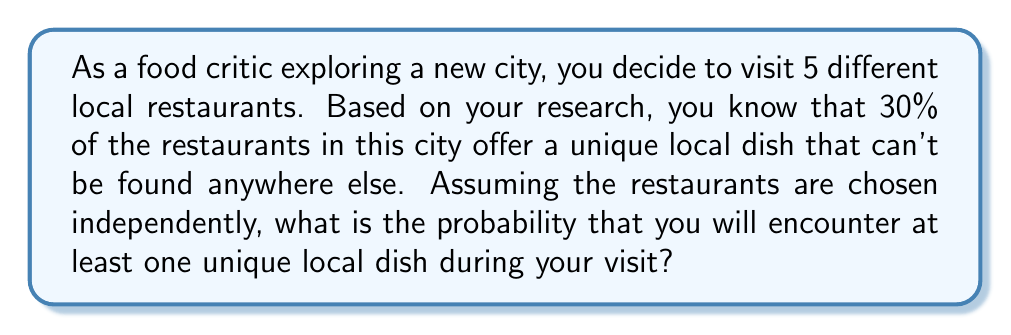Teach me how to tackle this problem. Let's approach this step-by-step:

1) First, let's define our probability:
   $p$ = probability of a restaurant offering a unique local dish = 0.30

2) The probability of not encountering a unique local dish at a single restaurant is:
   $1 - p = 1 - 0.30 = 0.70$

3) We want to find the probability of encountering at least one unique dish in 5 restaurants. It's easier to calculate the probability of not encountering any unique dishes and then subtract this from 1.

4) The probability of not encountering any unique dishes in 5 restaurants is:
   $$(0.70)^5 = 0.16807$$

5) Therefore, the probability of encountering at least one unique dish is:
   $$1 - (0.70)^5 = 1 - 0.16807 = 0.83193$$

6) We can express this as a percentage:
   $$0.83193 \times 100\% = 83.193\%$$

This result tells us that as a food critic, you have a high chance (about 83.2%) of encountering at least one unique local dish during your visit to 5 restaurants in this new city, which aligns with your belief that local cuisine is the best way to experience a new culture.
Answer: The probability of encountering at least one unique local dish during your visit to 5 restaurants is approximately 83.2% or 0.832. 